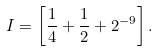Convert formula to latex. <formula><loc_0><loc_0><loc_500><loc_500>I = \left [ \frac { 1 } { 4 } + \frac { 1 } { 2 } + 2 ^ { - 9 } \right ] .</formula> 